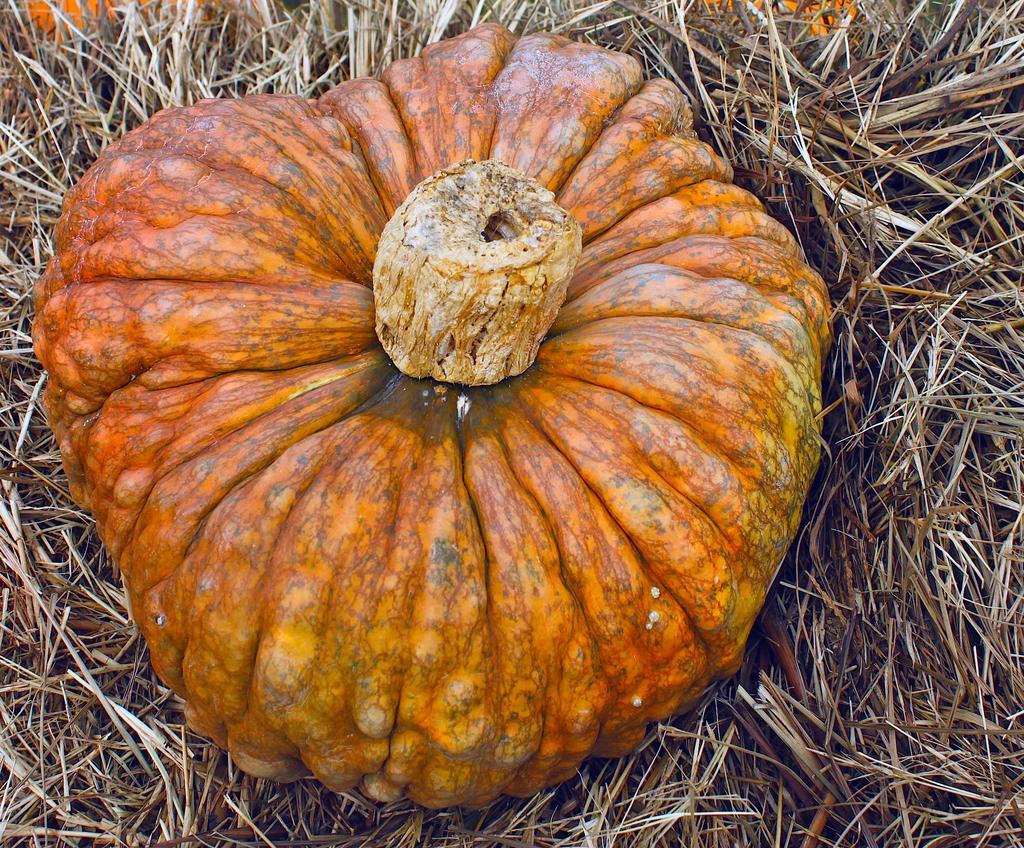Could you give a brief overview of what you see in this image? In this picture I can see a pumpkin in front which is on the dry grass. 